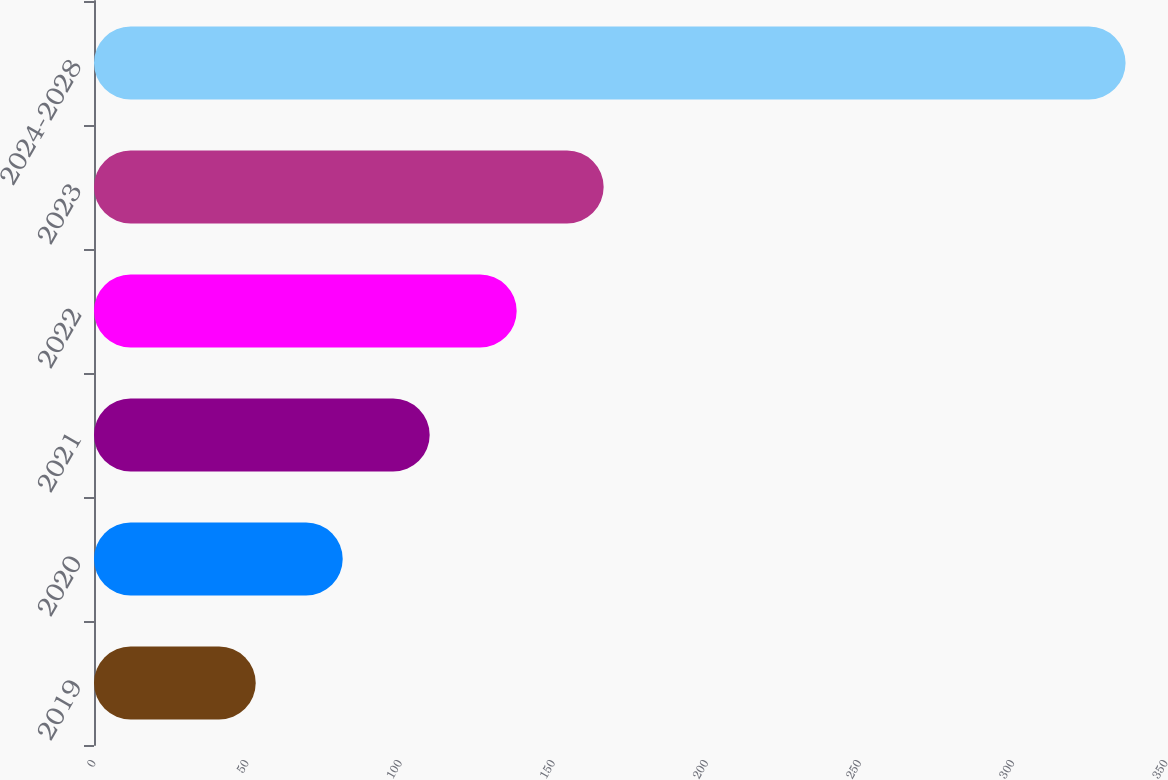Convert chart. <chart><loc_0><loc_0><loc_500><loc_500><bar_chart><fcel>2019<fcel>2020<fcel>2021<fcel>2022<fcel>2023<fcel>2024-2028<nl><fcel>52.8<fcel>81.2<fcel>109.6<fcel>138<fcel>166.4<fcel>336.8<nl></chart> 